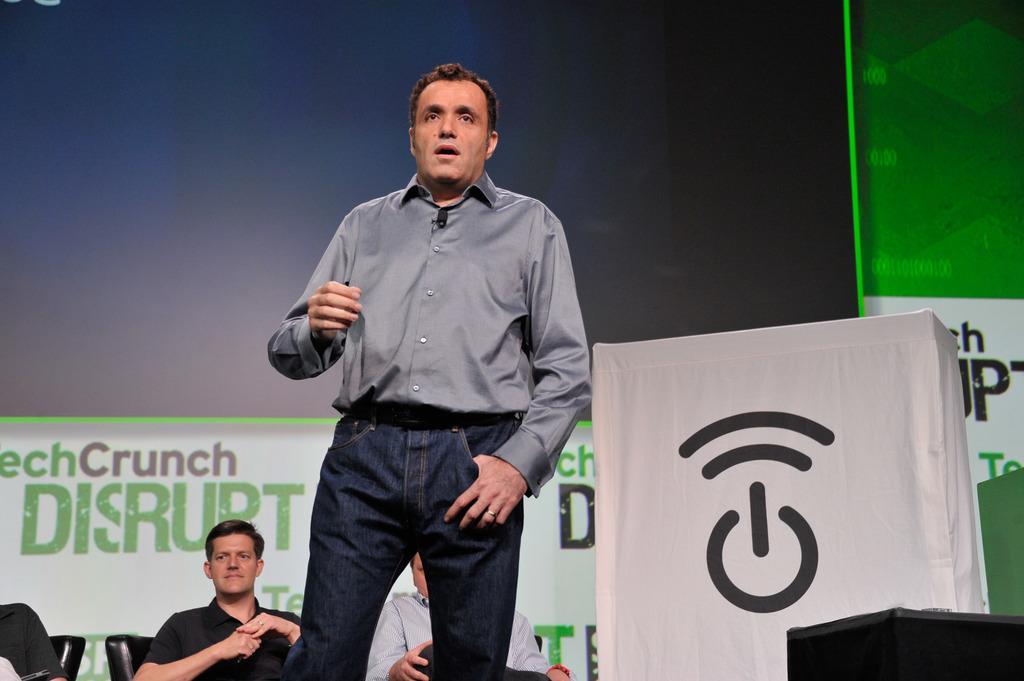How would you summarize this image in a sentence or two? Here there is a man standing at the podium and an object. In the background there are three men sitting on the chairs and we can also see a hoarding. 